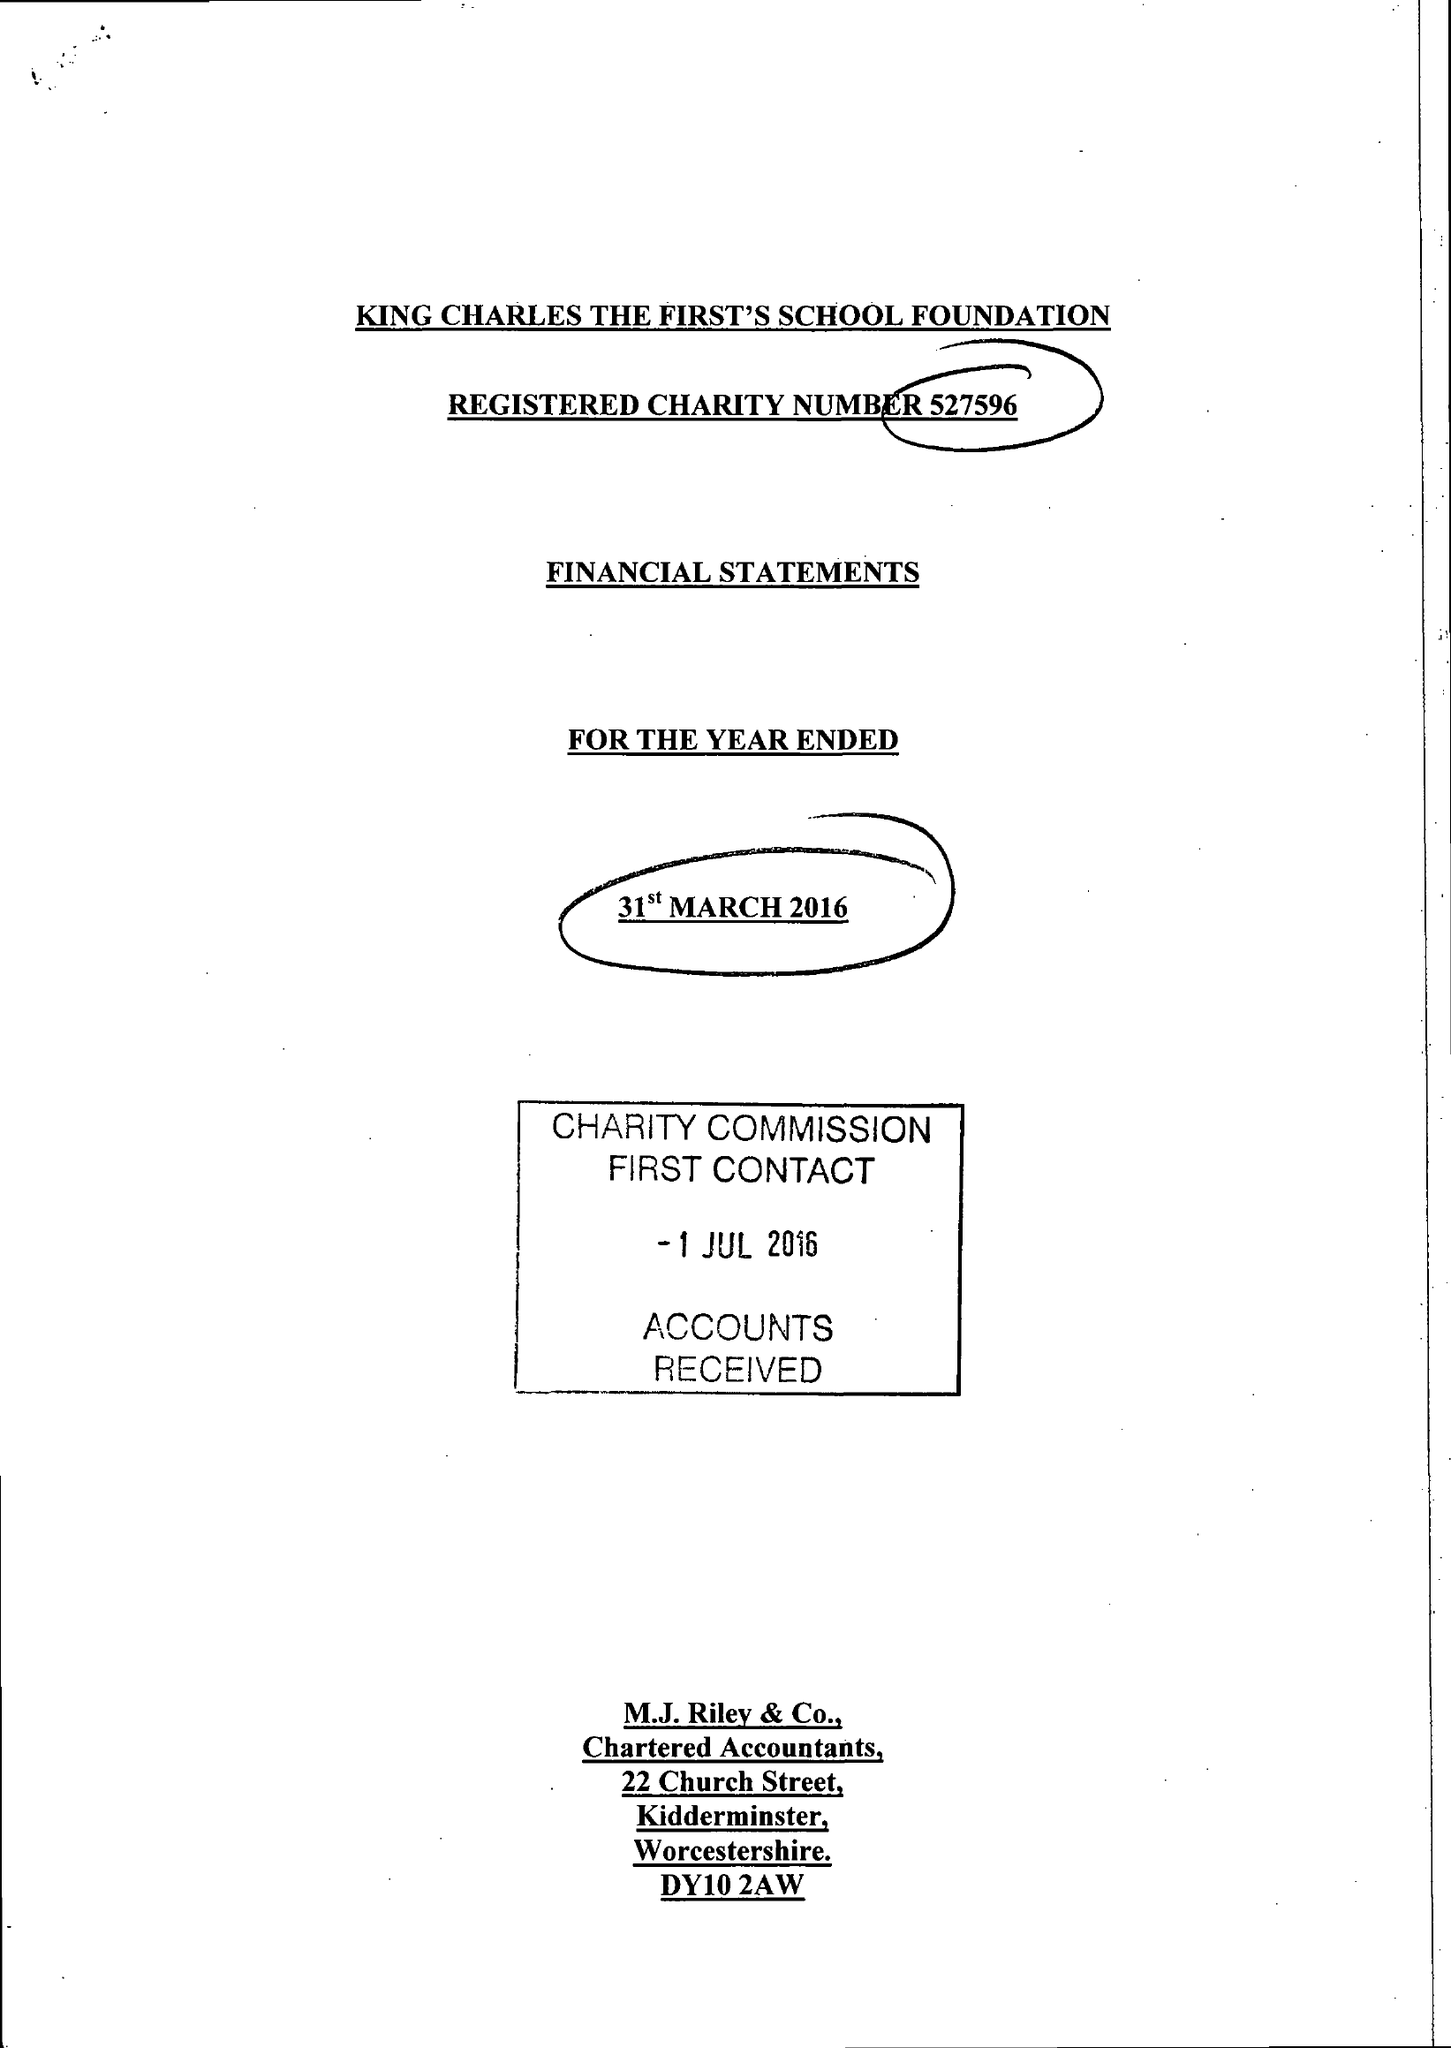What is the value for the report_date?
Answer the question using a single word or phrase. 2016-03-31 